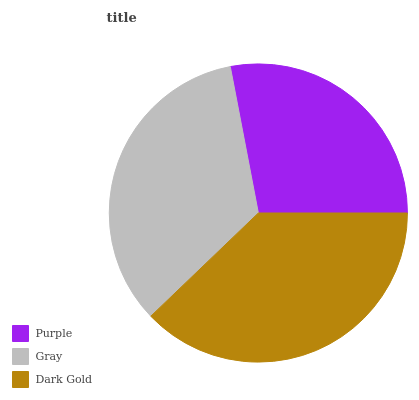Is Purple the minimum?
Answer yes or no. Yes. Is Dark Gold the maximum?
Answer yes or no. Yes. Is Gray the minimum?
Answer yes or no. No. Is Gray the maximum?
Answer yes or no. No. Is Gray greater than Purple?
Answer yes or no. Yes. Is Purple less than Gray?
Answer yes or no. Yes. Is Purple greater than Gray?
Answer yes or no. No. Is Gray less than Purple?
Answer yes or no. No. Is Gray the high median?
Answer yes or no. Yes. Is Gray the low median?
Answer yes or no. Yes. Is Purple the high median?
Answer yes or no. No. Is Dark Gold the low median?
Answer yes or no. No. 